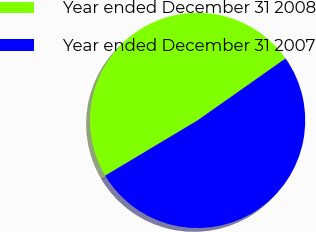Convert chart to OTSL. <chart><loc_0><loc_0><loc_500><loc_500><pie_chart><fcel>Year ended December 31 2008<fcel>Year ended December 31 2007<nl><fcel>48.82%<fcel>51.18%<nl></chart> 